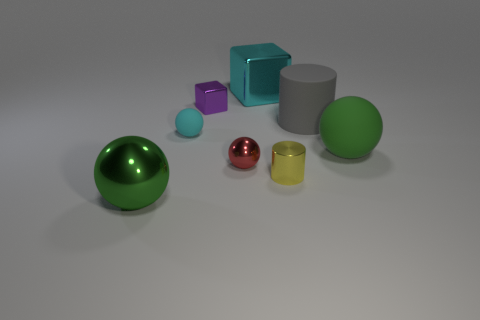Do the big sphere on the left side of the small purple metallic block and the object right of the big gray rubber thing have the same color?
Keep it short and to the point. Yes. How many things are cyan matte objects or tiny brown cylinders?
Provide a succinct answer. 1. What number of blue things are made of the same material as the small yellow thing?
Ensure brevity in your answer.  0. Are there fewer yellow cylinders than brown metal spheres?
Offer a very short reply. No. Is the small sphere left of the tiny shiny ball made of the same material as the large cyan cube?
Your answer should be very brief. No. How many balls are either gray things or matte things?
Offer a very short reply. 2. The large thing that is both behind the large green rubber sphere and left of the large gray rubber object has what shape?
Offer a very short reply. Cube. There is a block that is on the left side of the shiny ball right of the large object in front of the big green rubber thing; what color is it?
Provide a succinct answer. Purple. Is the number of small cyan spheres that are in front of the big green metallic ball less than the number of big gray shiny cylinders?
Your response must be concise. No. Does the big metallic object in front of the yellow cylinder have the same shape as the tiny thing that is behind the tiny cyan rubber object?
Your answer should be very brief. No. 